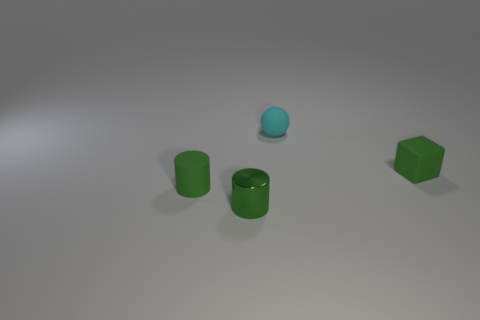Add 4 big yellow cubes. How many objects exist? 8 Subtract all blocks. How many objects are left? 3 Add 4 matte blocks. How many matte blocks exist? 5 Subtract 0 brown blocks. How many objects are left? 4 Subtract all large brown matte spheres. Subtract all small cyan spheres. How many objects are left? 3 Add 4 matte blocks. How many matte blocks are left? 5 